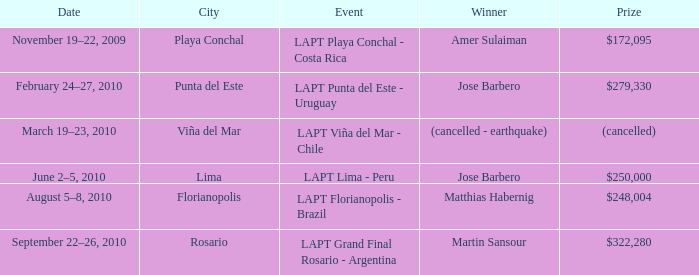Who is the triumphant person in the city of lima? Jose Barbero. 